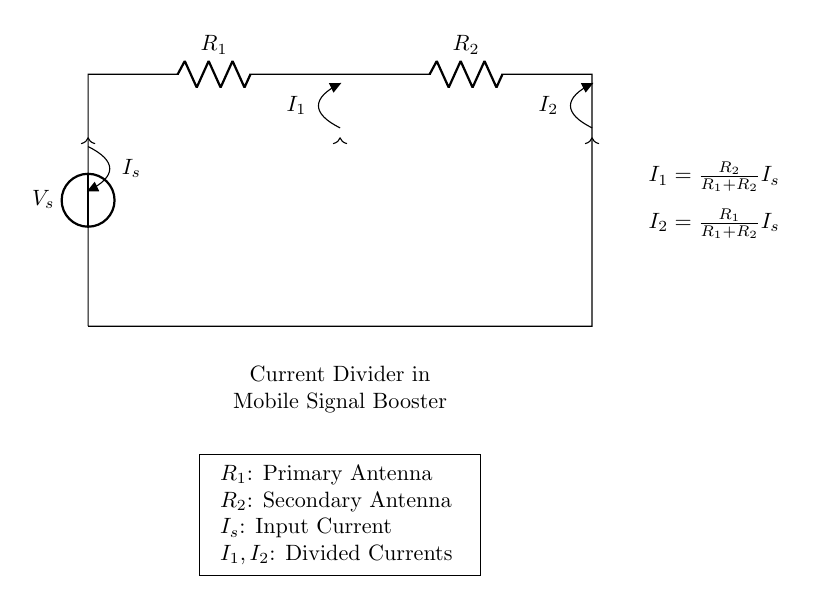What does R1 represent in the circuit? R1 represents the primary antenna in the mobile signal booster setup, which is indicated in the labeled components of the circuit diagram.
Answer: Primary antenna What is the input current in this circuit? The input current is represented as Is in the circuit diagram, which is the overall current supplied to the setup through the voltage source.
Answer: Is What is the relationship between I1 and I2? I1 and I2 represent the divided currents in the circuit, and their relationship is stated by the current divider equations given in the diagram. I1 increases when R2 increases, while I2 increases when R1 increases.
Answer: Divided currents How does increasing R2 affect I1? Increasing R2 results in an increase in I1, as described by the formula I1 = (R2 / (R1 + R2)) * Is, which shows that I1 is directly proportional to R2.
Answer: Increases What are the currents in this circuit? The currents in the circuit are Is, which is the input current, I1, which flows through R1, and I2, which flows through R2. These are defined in the diagram with their respective components and equations.
Answer: Is, I1, I2 What happens if both resistors are equal? If both resistors, R1 and R2, are equal, I1 and I2 will be equal as well, each receiving half of the input current Is, due to the nature of the current divider equation where the currents divide evenly.
Answer: Equal currents What is the function of the current divider in this circuit? The function of the current divider in this circuit is to distribute the input current Is into two separate paths, I1 and I2, allowing for the proper operation of both the primary and secondary antennas.
Answer: Distribute currents 